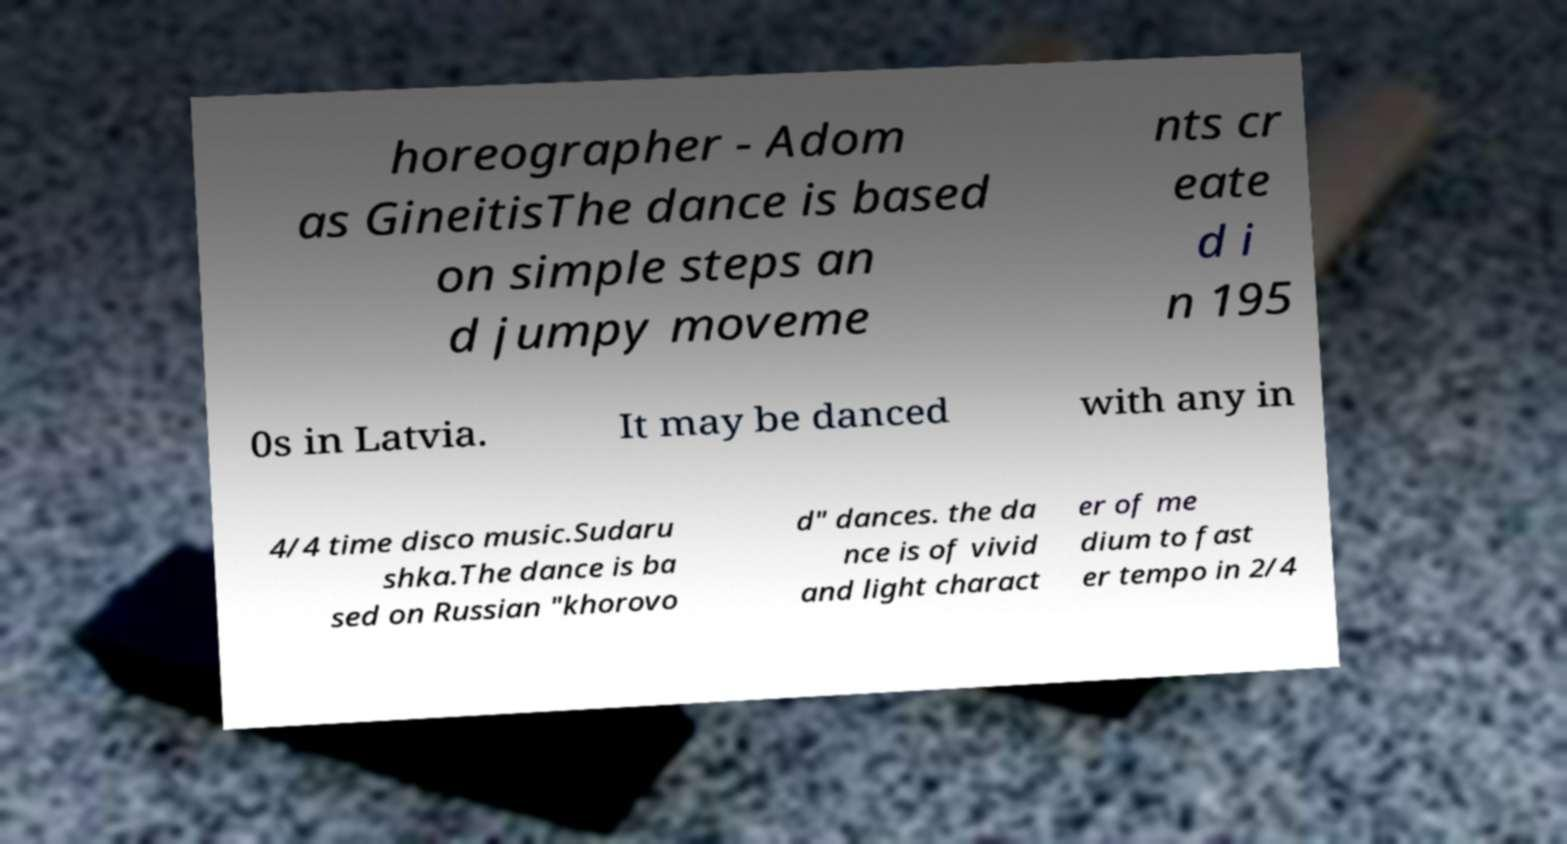There's text embedded in this image that I need extracted. Can you transcribe it verbatim? horeographer - Adom as GineitisThe dance is based on simple steps an d jumpy moveme nts cr eate d i n 195 0s in Latvia. It may be danced with any in 4/4 time disco music.Sudaru shka.The dance is ba sed on Russian "khorovo d" dances. the da nce is of vivid and light charact er of me dium to fast er tempo in 2/4 